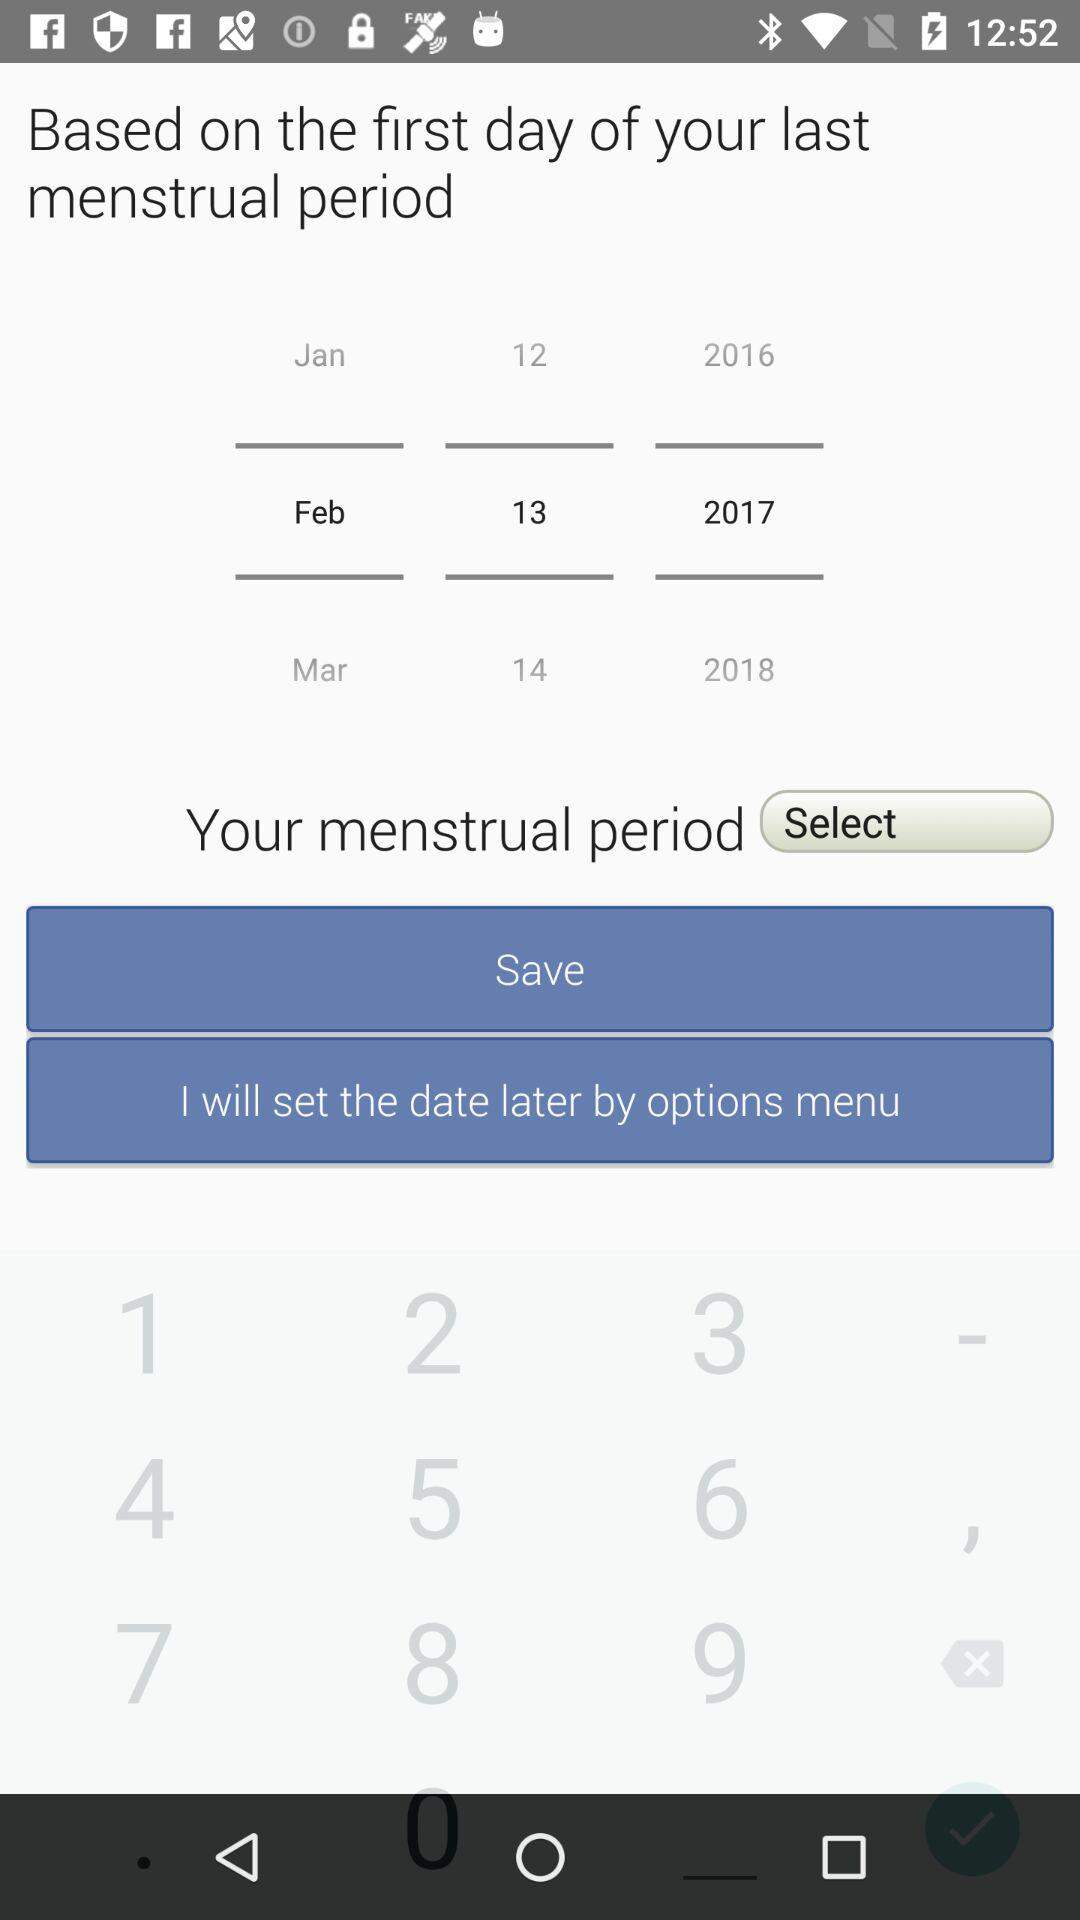How many months are displayed in the date picker?
Answer the question using a single word or phrase. 3 